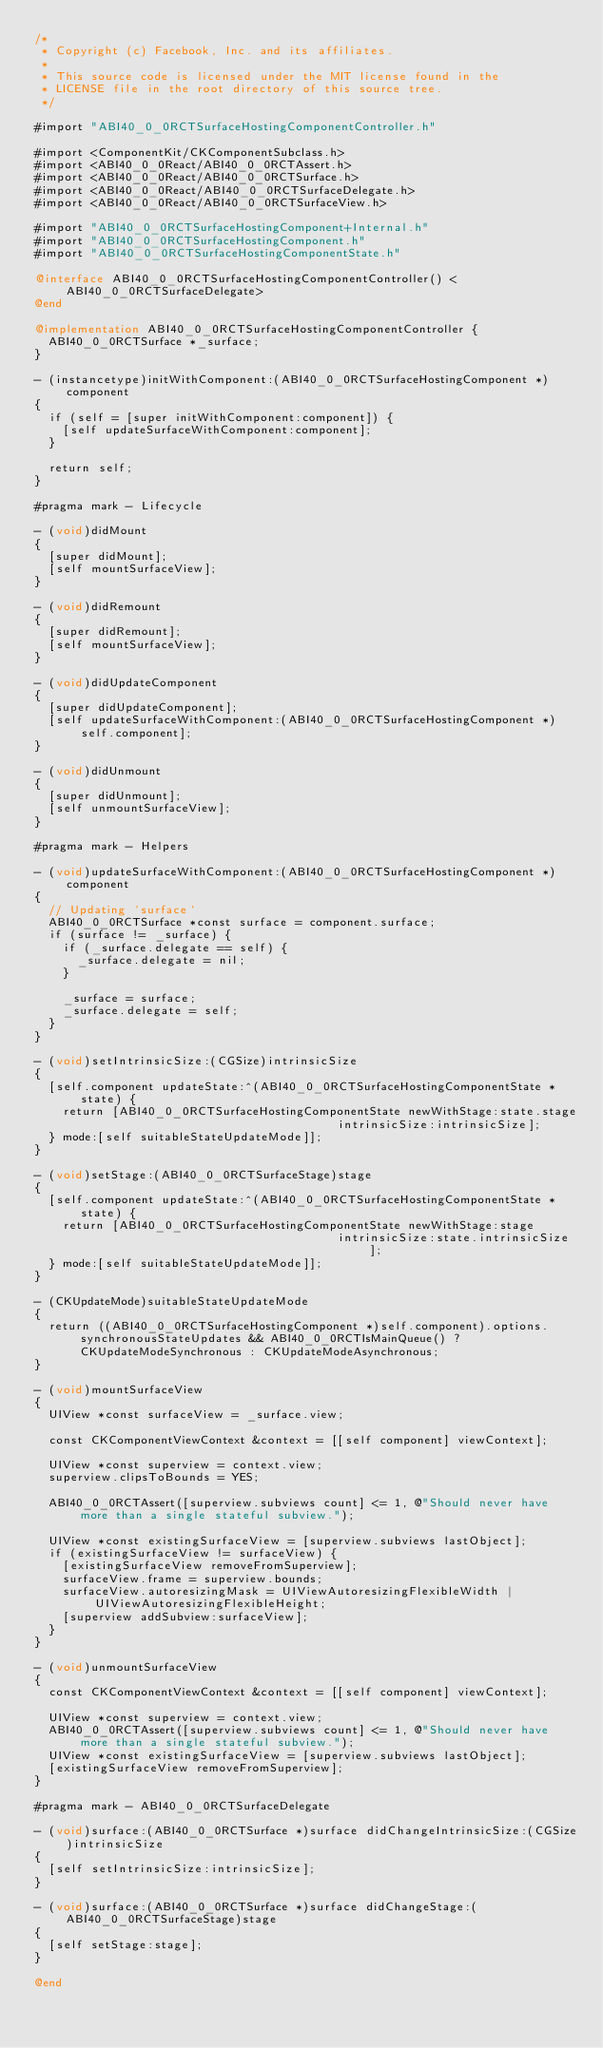<code> <loc_0><loc_0><loc_500><loc_500><_ObjectiveC_>/*
 * Copyright (c) Facebook, Inc. and its affiliates.
 *
 * This source code is licensed under the MIT license found in the
 * LICENSE file in the root directory of this source tree.
 */

#import "ABI40_0_0RCTSurfaceHostingComponentController.h"

#import <ComponentKit/CKComponentSubclass.h>
#import <ABI40_0_0React/ABI40_0_0RCTAssert.h>
#import <ABI40_0_0React/ABI40_0_0RCTSurface.h>
#import <ABI40_0_0React/ABI40_0_0RCTSurfaceDelegate.h>
#import <ABI40_0_0React/ABI40_0_0RCTSurfaceView.h>

#import "ABI40_0_0RCTSurfaceHostingComponent+Internal.h"
#import "ABI40_0_0RCTSurfaceHostingComponent.h"
#import "ABI40_0_0RCTSurfaceHostingComponentState.h"

@interface ABI40_0_0RCTSurfaceHostingComponentController() <ABI40_0_0RCTSurfaceDelegate>
@end

@implementation ABI40_0_0RCTSurfaceHostingComponentController {
  ABI40_0_0RCTSurface *_surface;
}

- (instancetype)initWithComponent:(ABI40_0_0RCTSurfaceHostingComponent *)component
{
  if (self = [super initWithComponent:component]) {
    [self updateSurfaceWithComponent:component];
  }

  return self;
}

#pragma mark - Lifecycle

- (void)didMount
{
  [super didMount];
  [self mountSurfaceView];
}

- (void)didRemount
{
  [super didRemount];
  [self mountSurfaceView];
}

- (void)didUpdateComponent
{
  [super didUpdateComponent];
  [self updateSurfaceWithComponent:(ABI40_0_0RCTSurfaceHostingComponent *)self.component];
}

- (void)didUnmount
{
  [super didUnmount];
  [self unmountSurfaceView];
}

#pragma mark - Helpers

- (void)updateSurfaceWithComponent:(ABI40_0_0RCTSurfaceHostingComponent *)component
{
  // Updating `surface`
  ABI40_0_0RCTSurface *const surface = component.surface;
  if (surface != _surface) {
    if (_surface.delegate == self) {
      _surface.delegate = nil;
    }

    _surface = surface;
    _surface.delegate = self;
  }
}

- (void)setIntrinsicSize:(CGSize)intrinsicSize
{
  [self.component updateState:^(ABI40_0_0RCTSurfaceHostingComponentState *state) {
    return [ABI40_0_0RCTSurfaceHostingComponentState newWithStage:state.stage
                                           intrinsicSize:intrinsicSize];
  } mode:[self suitableStateUpdateMode]];
}

- (void)setStage:(ABI40_0_0RCTSurfaceStage)stage
{
  [self.component updateState:^(ABI40_0_0RCTSurfaceHostingComponentState *state) {
    return [ABI40_0_0RCTSurfaceHostingComponentState newWithStage:stage
                                           intrinsicSize:state.intrinsicSize];
  } mode:[self suitableStateUpdateMode]];
}

- (CKUpdateMode)suitableStateUpdateMode
{
  return ((ABI40_0_0RCTSurfaceHostingComponent *)self.component).options.synchronousStateUpdates && ABI40_0_0RCTIsMainQueue() ? CKUpdateModeSynchronous : CKUpdateModeAsynchronous;
}

- (void)mountSurfaceView
{
  UIView *const surfaceView = _surface.view;

  const CKComponentViewContext &context = [[self component] viewContext];

  UIView *const superview = context.view;
  superview.clipsToBounds = YES;

  ABI40_0_0RCTAssert([superview.subviews count] <= 1, @"Should never have more than a single stateful subview.");

  UIView *const existingSurfaceView = [superview.subviews lastObject];
  if (existingSurfaceView != surfaceView) {
    [existingSurfaceView removeFromSuperview];
    surfaceView.frame = superview.bounds;
    surfaceView.autoresizingMask = UIViewAutoresizingFlexibleWidth | UIViewAutoresizingFlexibleHeight;
    [superview addSubview:surfaceView];
  }
}

- (void)unmountSurfaceView
{
  const CKComponentViewContext &context = [[self component] viewContext];

  UIView *const superview = context.view;
  ABI40_0_0RCTAssert([superview.subviews count] <= 1, @"Should never have more than a single stateful subview.");
  UIView *const existingSurfaceView = [superview.subviews lastObject];
  [existingSurfaceView removeFromSuperview];
}

#pragma mark - ABI40_0_0RCTSurfaceDelegate

- (void)surface:(ABI40_0_0RCTSurface *)surface didChangeIntrinsicSize:(CGSize)intrinsicSize
{
  [self setIntrinsicSize:intrinsicSize];
}

- (void)surface:(ABI40_0_0RCTSurface *)surface didChangeStage:(ABI40_0_0RCTSurfaceStage)stage
{
  [self setStage:stage];
}

@end
</code> 